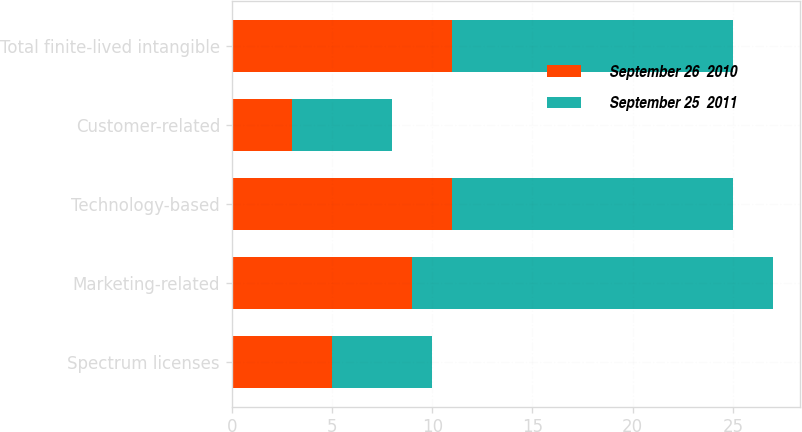<chart> <loc_0><loc_0><loc_500><loc_500><stacked_bar_chart><ecel><fcel>Spectrum licenses<fcel>Marketing-related<fcel>Technology-based<fcel>Customer-related<fcel>Total finite-lived intangible<nl><fcel>September 26  2010<fcel>5<fcel>9<fcel>11<fcel>3<fcel>11<nl><fcel>September 25  2011<fcel>5<fcel>18<fcel>14<fcel>5<fcel>14<nl></chart> 